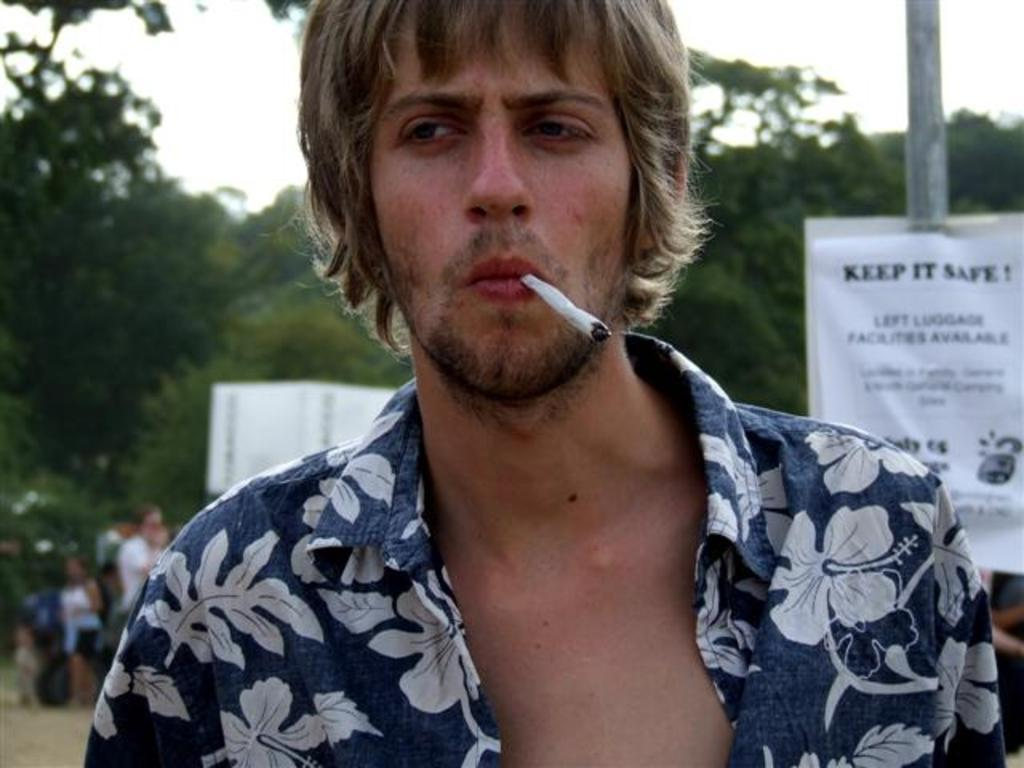Who is present in the image? There is a man in the image. What is the man holding in his mouth? The man has a cigarette in his mouth. What can be seen in the background of the image? There is an advertisement attached to a pole, trees, people standing on the road, and the sky visible in the background. What type of harbor can be seen in the image? There is no harbor present in the image. How many buildings are visible in the image? The image does not show any buildings; it only features a man, a cigarette, an advertisement, trees, people, and the sky. 